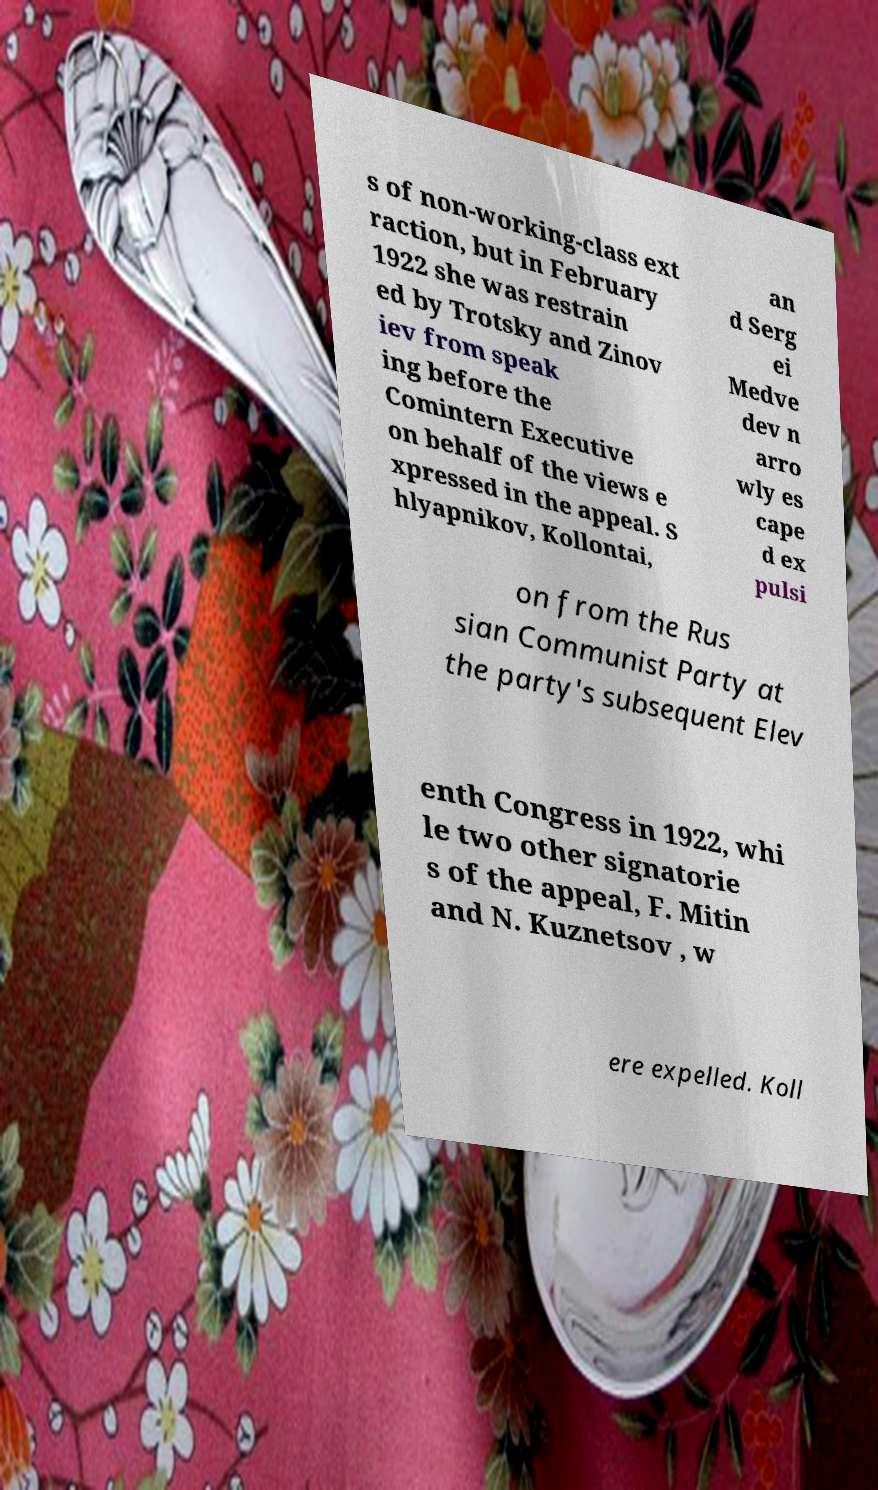I need the written content from this picture converted into text. Can you do that? s of non-working-class ext raction, but in February 1922 she was restrain ed by Trotsky and Zinov iev from speak ing before the Comintern Executive on behalf of the views e xpressed in the appeal. S hlyapnikov, Kollontai, an d Serg ei Medve dev n arro wly es cape d ex pulsi on from the Rus sian Communist Party at the party's subsequent Elev enth Congress in 1922, whi le two other signatorie s of the appeal, F. Mitin and N. Kuznetsov , w ere expelled. Koll 